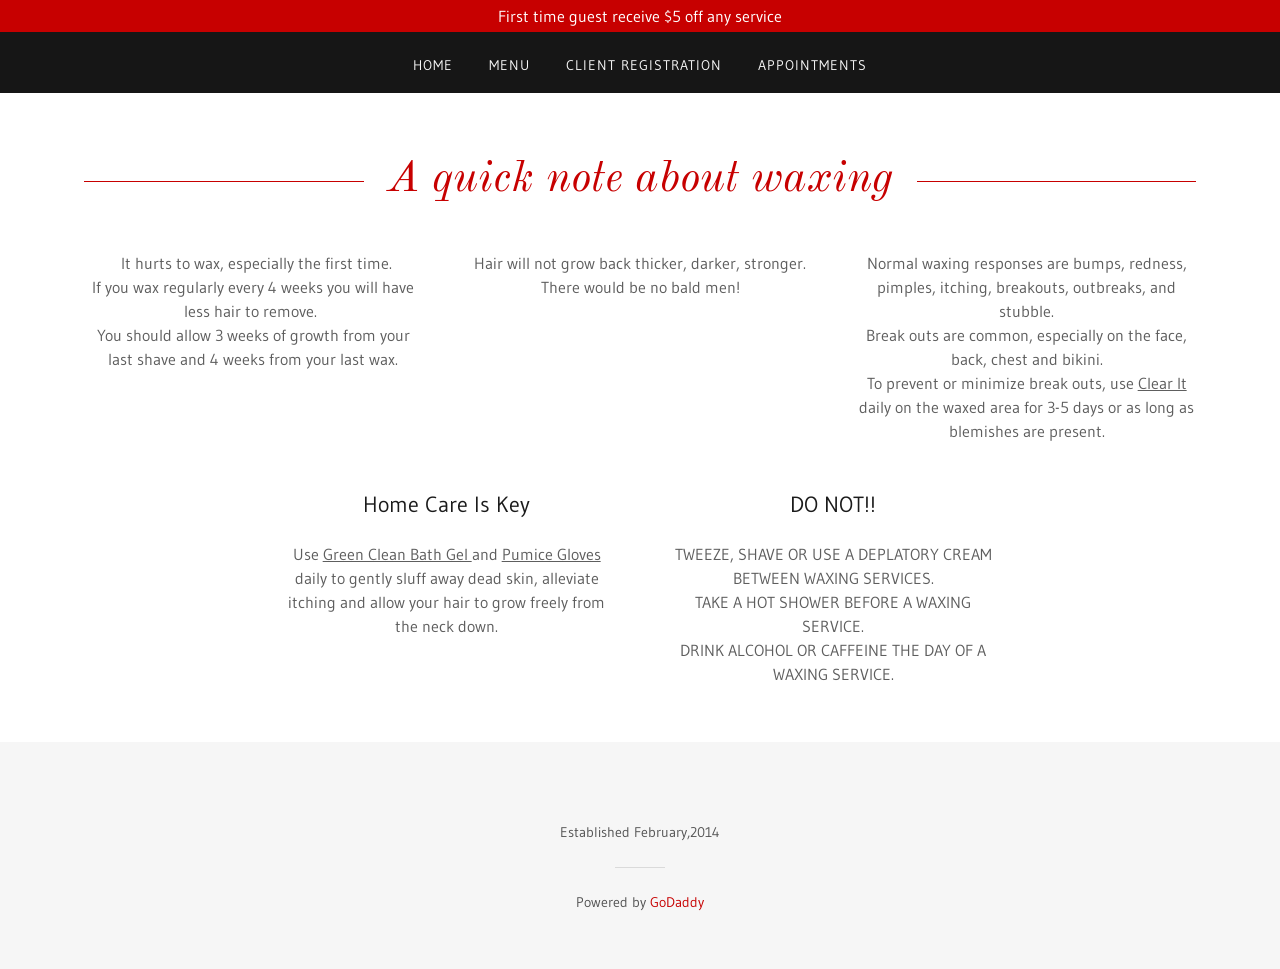What are some recommended aftercare tips to minimize discomfort after waxing? To minimize discomfort and potential skin irritation after waxing, it's beneficial to apply a gentle, soothing lotion or aloe vera to the waxed areas to calm the skin. It's also important to avoid direct sunlight and not to take extremely hot showers for the first 24 hours following a waxing session. Wearing loose clothing can help avoid friction that might irritate the skin further. 